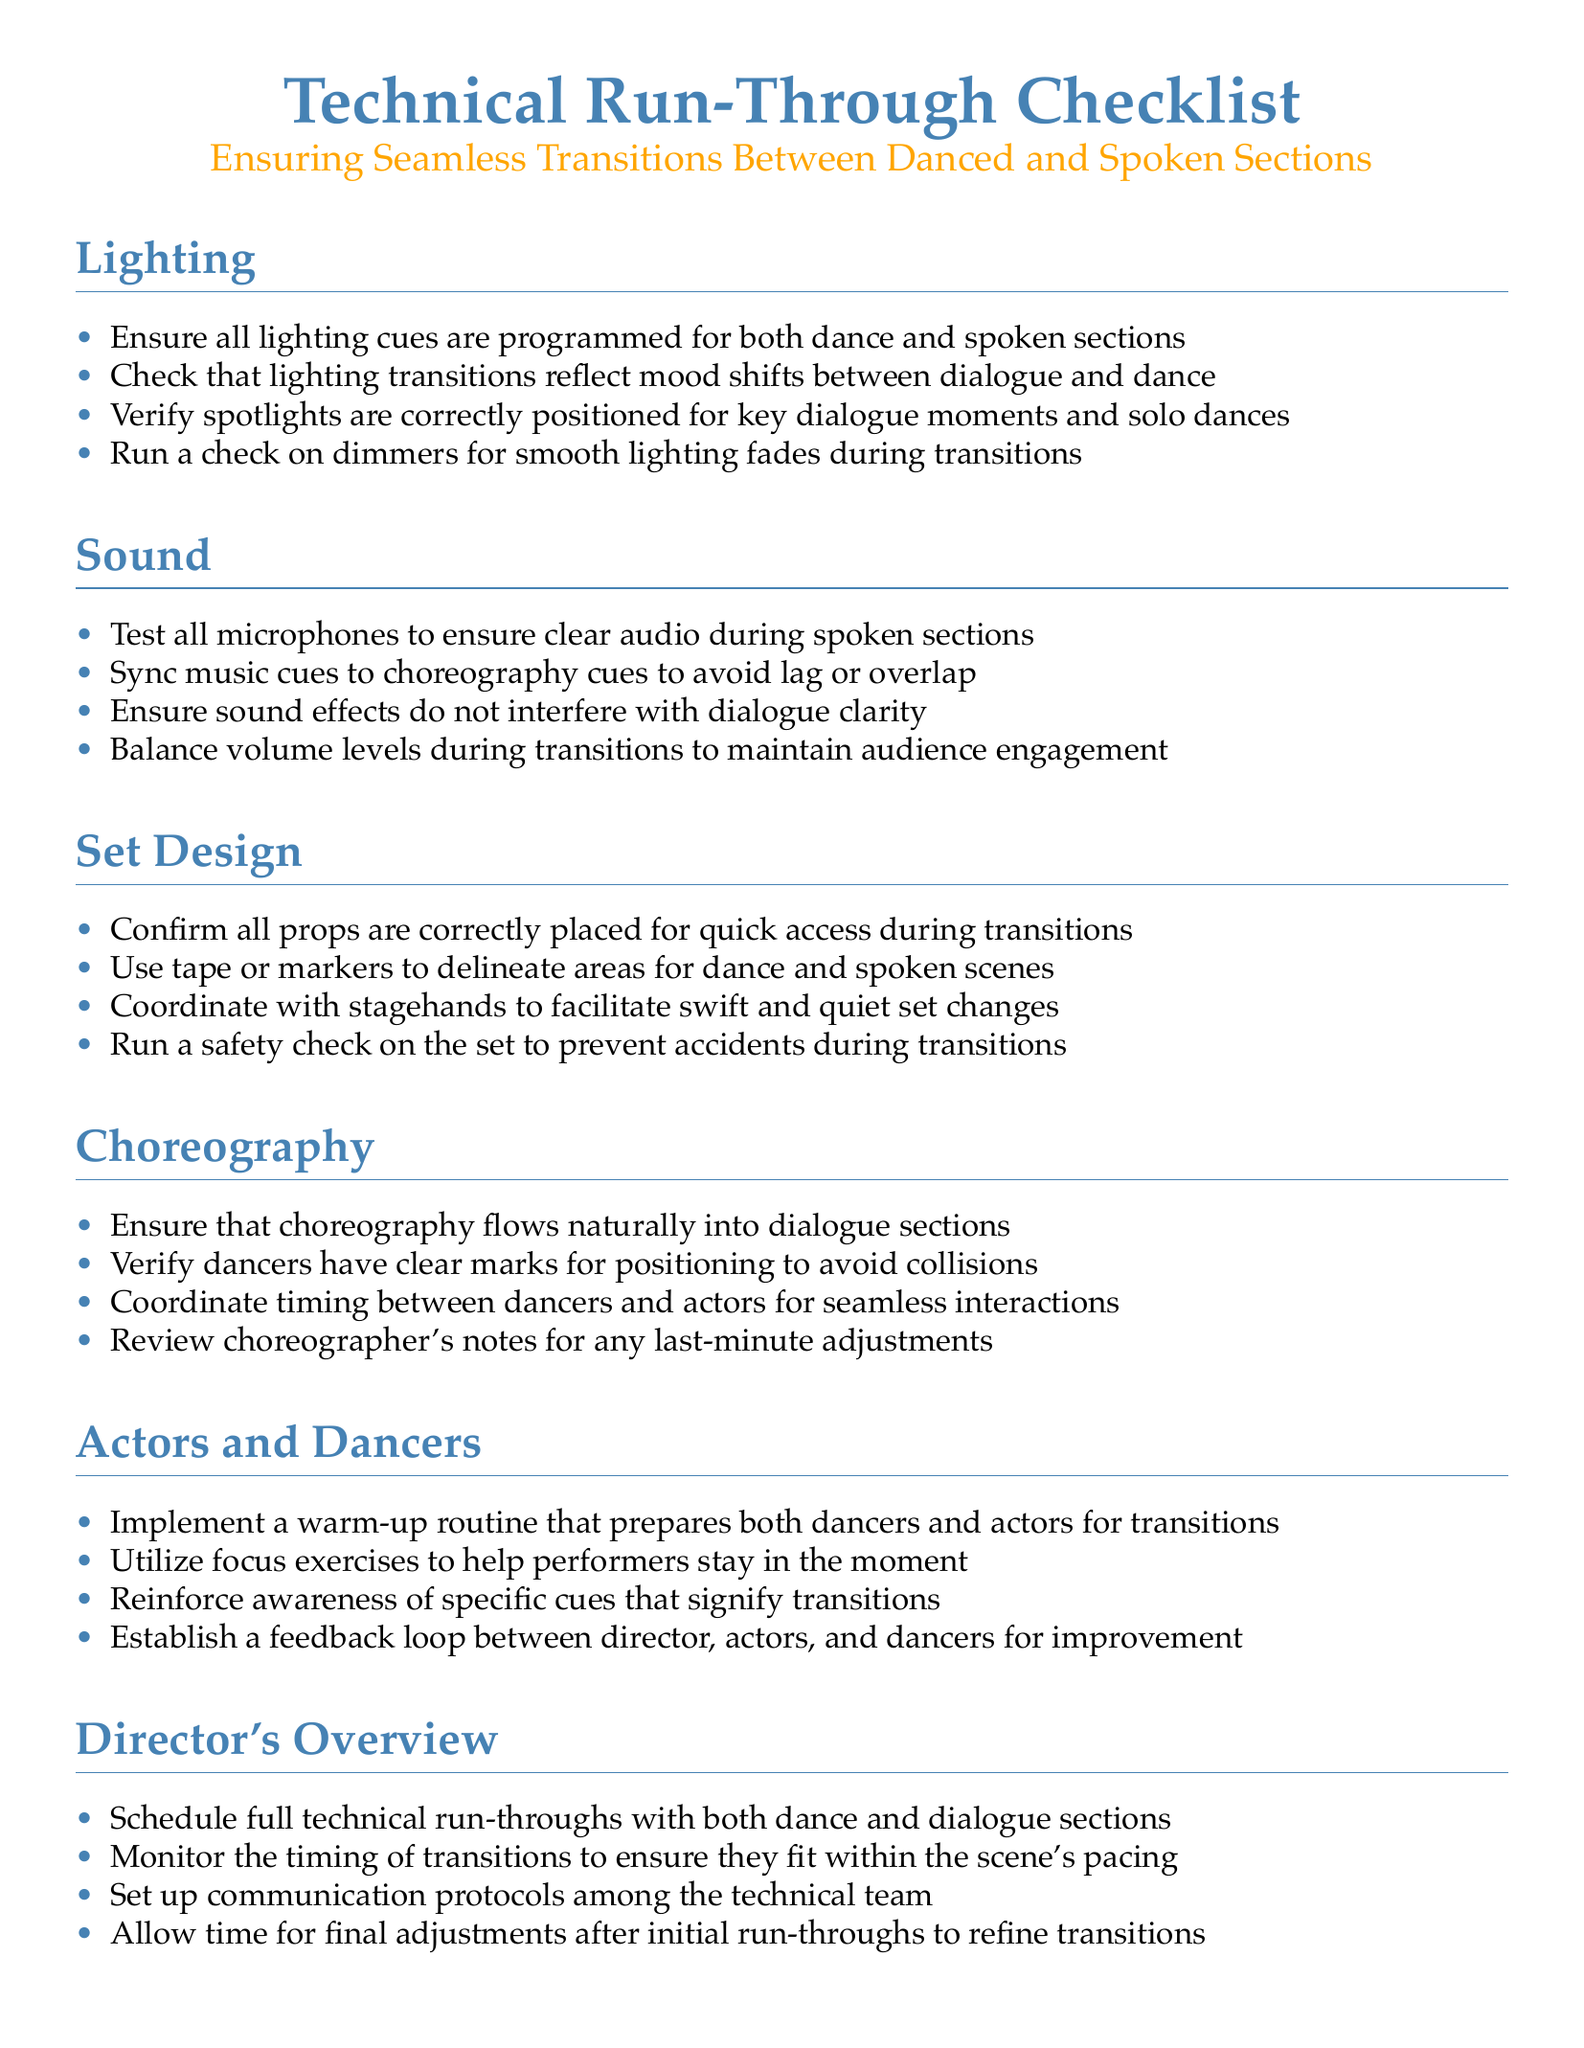What is the main focus of the checklist? The checklist focuses on ensuring smooth transitions between danced and spoken sections in a production.
Answer: Seamless Transitions Between Danced and Spoken Sections How many sections are included in the checklist? The checklist consists of different sections that cover various technical aspects, totaling six.
Answer: Six What is one of the tasks listed under Lighting? One of the tasks requires programming lighting cues for dance and spoken sections.
Answer: Ensure all lighting cues are programmed for both dance and spoken sections What should be confirmed regarding props in Set Design? It is essential to confirm that all props are correctly placed for quick access during transitions.
Answer: Confirm all props are correctly placed for quick access during transitions What type of routine is suggested for actors and dancers? A warm-up routine is suggested to prepare both dancers and actors for transitions.
Answer: Implement a warm-up routine What is the role of the director in this checklist? The director is responsible for monitoring the timing of transitions to ensure they fit within the scene's pacing.
Answer: Monitor the timing of transitions What kind of feedback loop is established in Actors and Dancers? A feedback loop is established between the director, actors, and dancers to encourage ongoing improvement.
Answer: Establish a feedback loop between director, actors, and dancers for improvement 